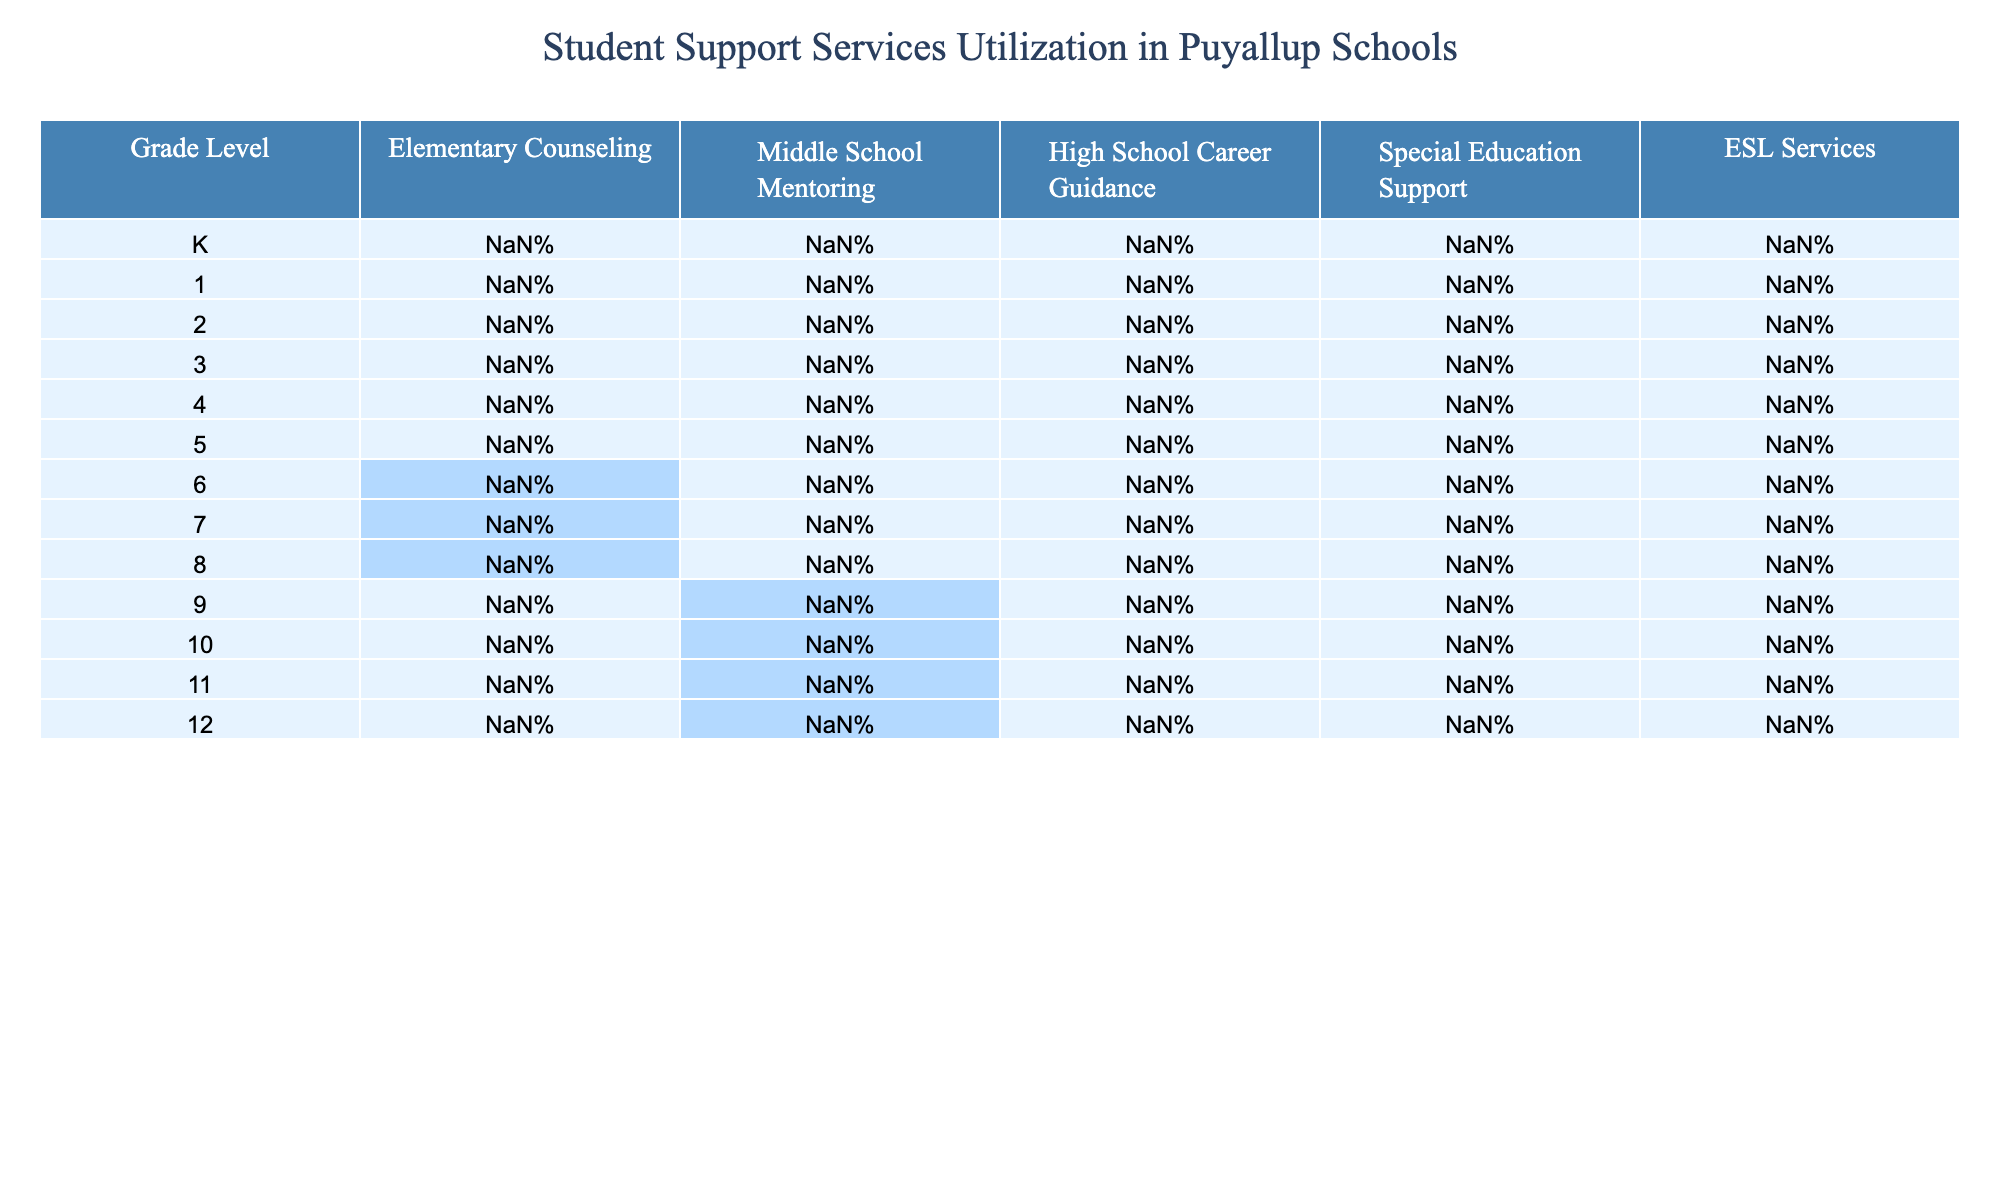What is the utilization rate for Elementary Counseling in 5th grade? According to the table, the utilization rate for Elementary Counseling in 5th grade is found in the corresponding row for grade 5, which states 28%.
Answer: 28% Which grade level has the highest percentage of Middle School Mentoring? The highest percentage of Middle School Mentoring is found in the 8th grade, where the rate is 40%.
Answer: 40% Is there any utilization of High School Career Guidance services in grades K through 8? By examining the table, there are no utilization rates for High School Career Guidance in grades K, 1, 2, 3, 4, 5, 6, 7, and 8, as all these entries show 0%.
Answer: Yes What is the total percentage of Special Education Support utilized in grades 6 to 8? To find the total percentage for Special Education Support in grades 6 to 8, we add the percentages: 13% (6th grade) + 14% (7th grade) + 14% (8th grade) = 41%.
Answer: 41% Which services have a higher utilization rate in elementary grades compared to middle and high school grades? By comparing the data, Elementary Counseling, ESL Services, and Special Education Support have higher rates in elementary grades (K-5) when checking the percentages against middle school and high school data. For example, in 5th grade, Elementary Counseling is 28%, whereas it is 0% in middle and high school.
Answer: Yes What is the average percentage of ESL Services utilized across all grade levels? To calculate the average, sum all the ESL Services percentages: (6% + 7% + 8% + 7% + 6% + 5% + 4% + 3% + 3% + 2% + 2% + 1%) = 54%. There are 12 grade levels, so the average is 54% / 12 = 4.5%.
Answer: 4.5% For which grade is the utilization rate of Special Education Support the highest? The utilization rate of Special Education Support is highest in 12th grade at 60%, as clearly shown in the respective row.
Answer: 12th grade Do any grades report a 0% utilization for ESL Services? Checking the data, both 9th and 10th grade show an ESL Services utilization of 2%, which does not indicate 0%. However, grades K to 8 show differing percentages, confirming that higher grades report different utilization rates, but no complete 0% utilization exists.
Answer: No What is the change in utilization rate of High School Career Guidance from 9th to 12th grade? By looking at the table, the utilization rate changes from 45% in 9th grade to 60% in 12th grade, showing an increase of 15%.
Answer: 15% increase Which service is entirely unused in middle school? By analyzing the middle school columns for grades 6, 7, and 8, it is evident that High School Career Guidance shows a 0% utilization rate across those grades.
Answer: High School Career Guidance 